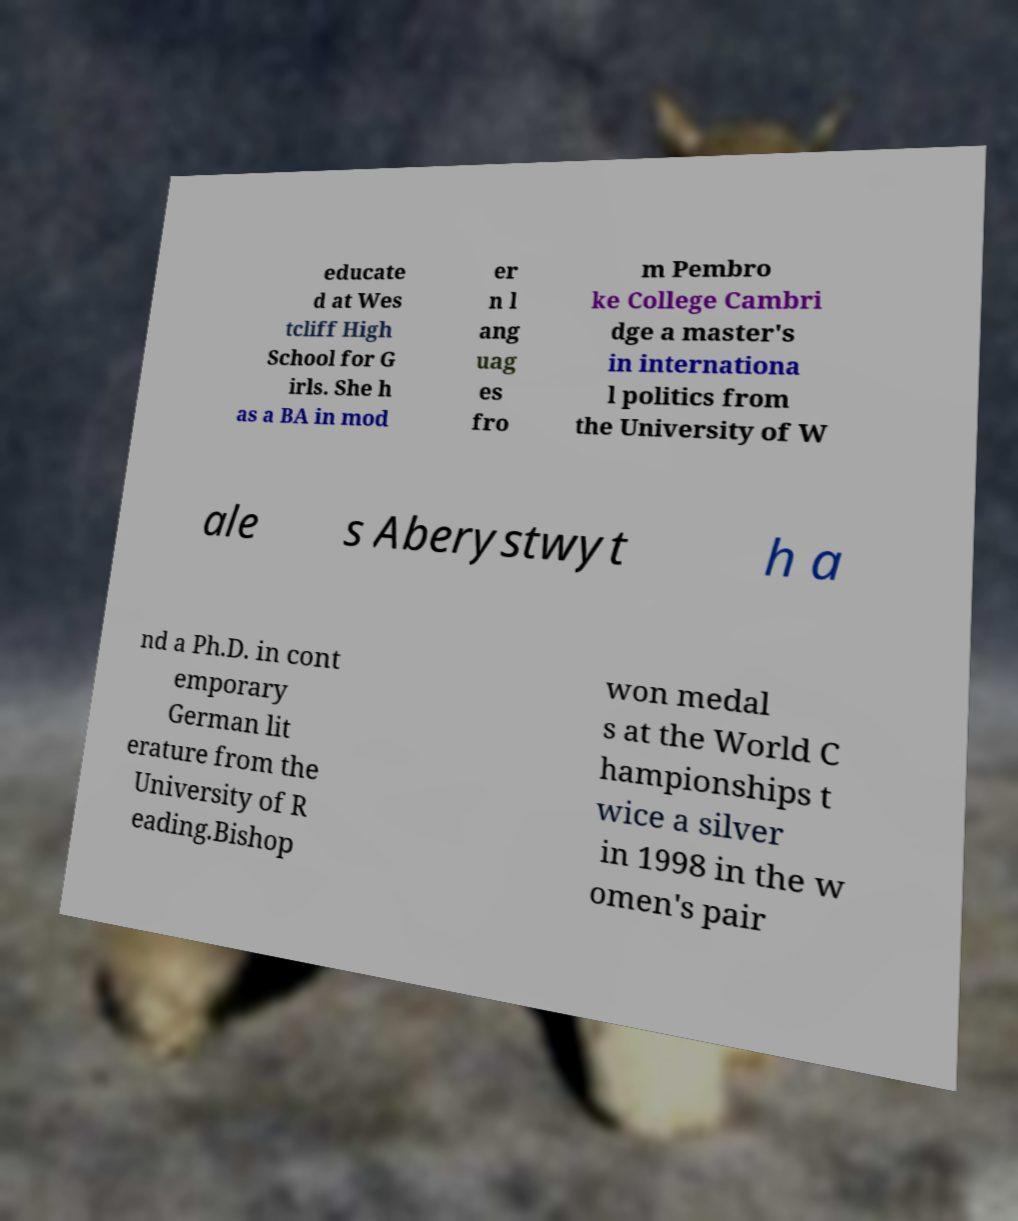Can you accurately transcribe the text from the provided image for me? educate d at Wes tcliff High School for G irls. She h as a BA in mod er n l ang uag es fro m Pembro ke College Cambri dge a master's in internationa l politics from the University of W ale s Aberystwyt h a nd a Ph.D. in cont emporary German lit erature from the University of R eading.Bishop won medal s at the World C hampionships t wice a silver in 1998 in the w omen's pair 